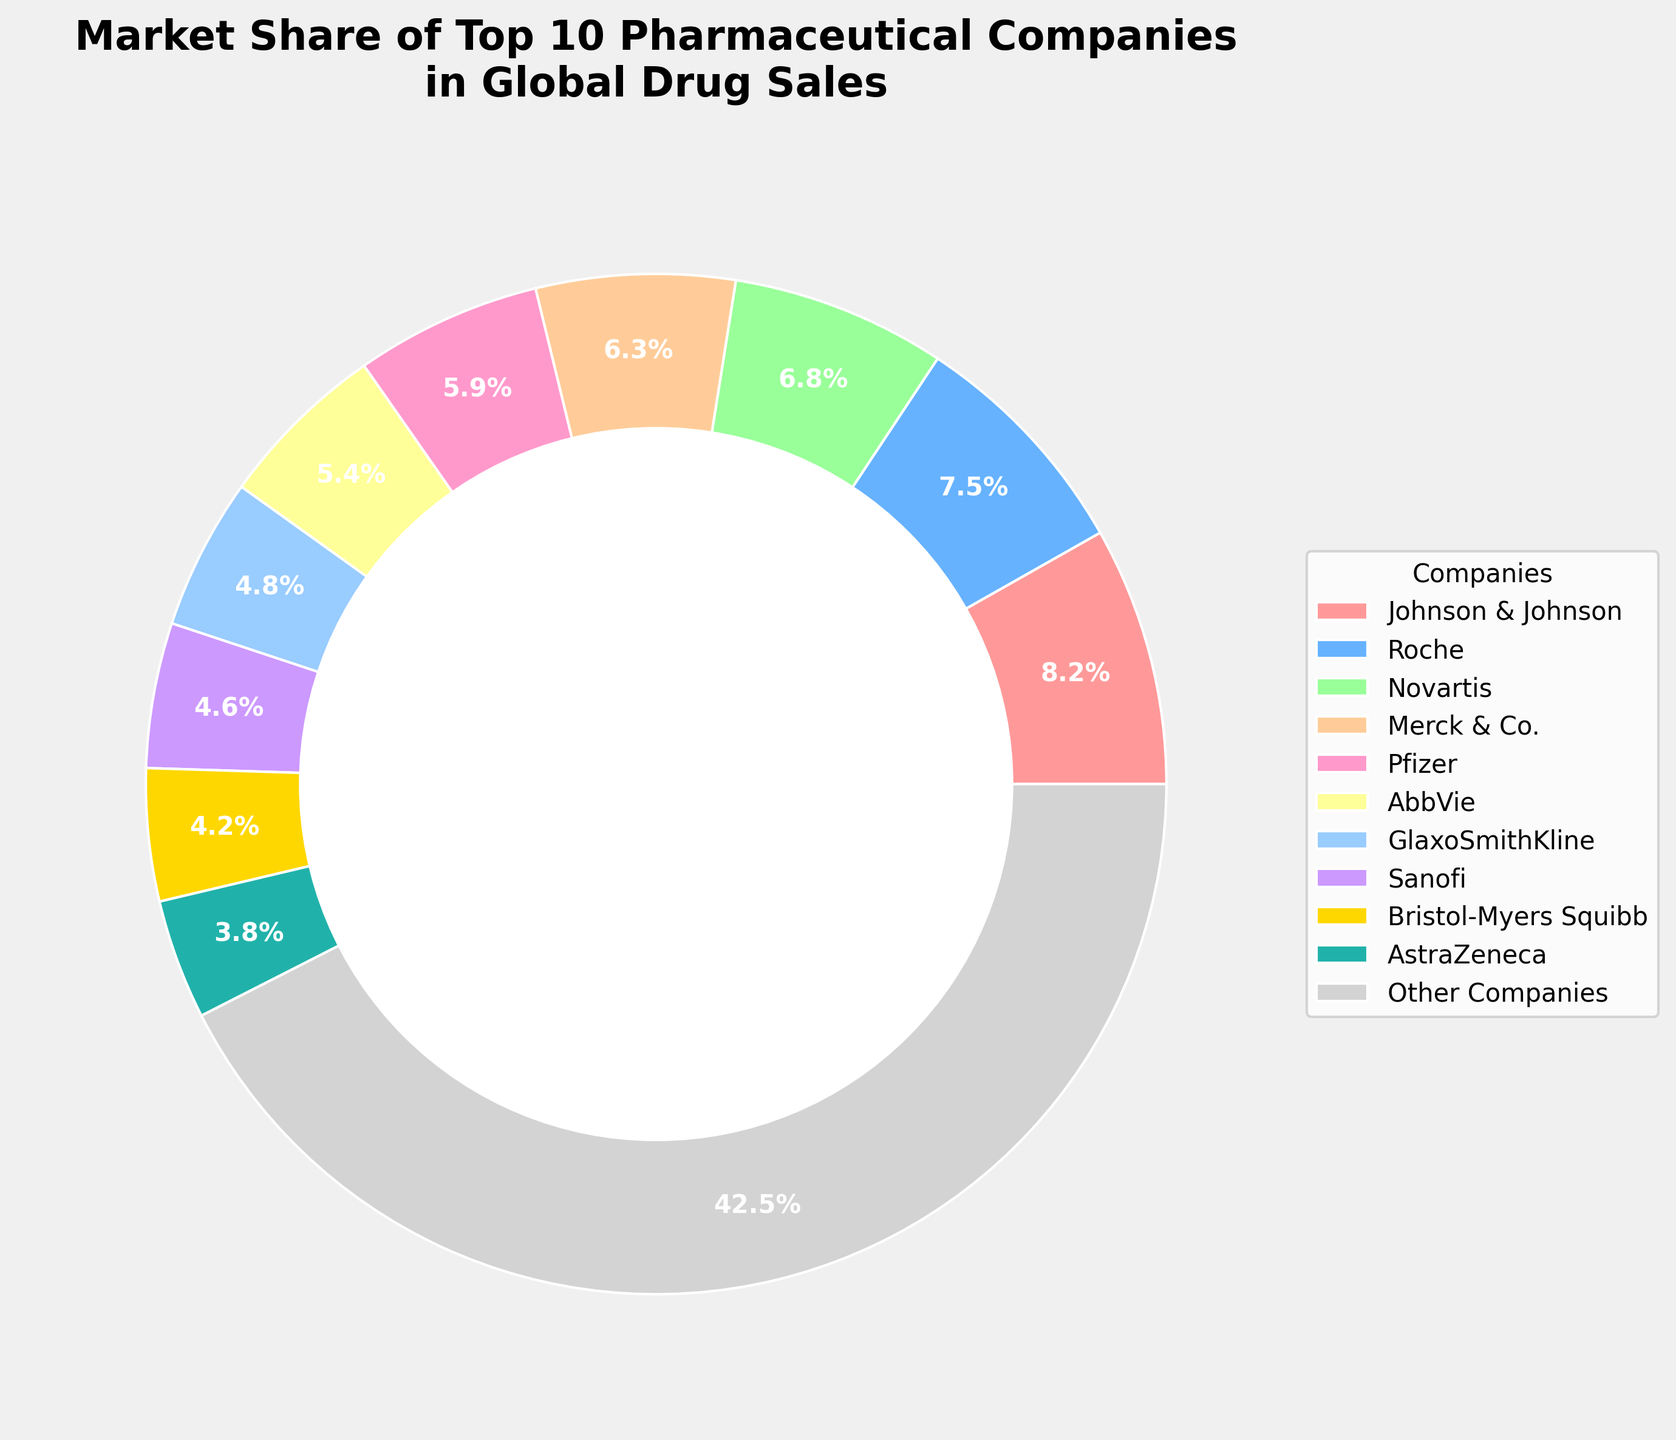Which company has the largest market share? From the pie chart, the largest wedge will correspond to the company with the highest market share percentage. In this case, Johnson & Johnson has the largest market share.
Answer: Johnson & Johnson Which company has the smallest market share among the top 10? The pie chart shows various market shares for each company. The smallest wedge for the top 10 companies belongs to AstraZeneca with a market share of 3.8%.
Answer: AstraZeneca What is the combined market share of Pfizer and AbbVie? From the pie chart, the market shares of Pfizer and AbbVie are 5.9% and 5.4% respectively. Adding these values gives 5.9% + 5.4% = 11.3%.
Answer: 11.3% Which companies have a market share greater than 5%? From the pie chart, we can see that Johnson & Johnson (8.2%), Roche (7.5%), Novartis (6.8%), Merck & Co. (6.3%), and Pfizer (5.9%) have market shares greater than 5%.
Answer: Johnson & Johnson, Roche, Novartis, Merck & Co., Pfizer Is GlaxoSmithKline's market share greater than Sanofi's? According to the pie chart, GlaxoSmithKline has a market share of 4.8% and Sanofi has a market share of 4.6%. Since 4.8% is greater than 4.6%, GlaxoSmithKline's market share is indeed greater.
Answer: Yes What is the market share difference between Roche and Novartis? Roche's market share is 7.5% and Novartis's market share is 6.8%. The difference is 7.5% - 6.8% = 0.7%.
Answer: 0.7% Which color is used to represent Sanofi in the chart? In the pie chart, each company is represented by a specific color. Sanofi's wedge is colored light yellow.
Answer: Light yellow What is the average market share of the top 10 pharmaceutical companies (excluding 'Other Companies')? The market shares of the top 10 companies are: 8.2%, 7.5%, 6.8%, 6.3%, 5.9%, 5.4%, 4.8%, 4.6%, 4.2%, and 3.8%. Summing these values gives 57.5%. The average is 57.5% / 10 = 5.75%.
Answer: 5.75% What percentage of the market share is held by companies not listed in the top 10? According to the pie chart, 'Other Companies' have a market share of 42.5%.
Answer: 42.5% If Merck & Co. increased their market share by 1.2%, what would their new market share be? Merck & Co. currently have a market share of 6.3%. An increase of 1.2% would give them a new market share of 6.3% + 1.2% = 7.5%.
Answer: 7.5% 